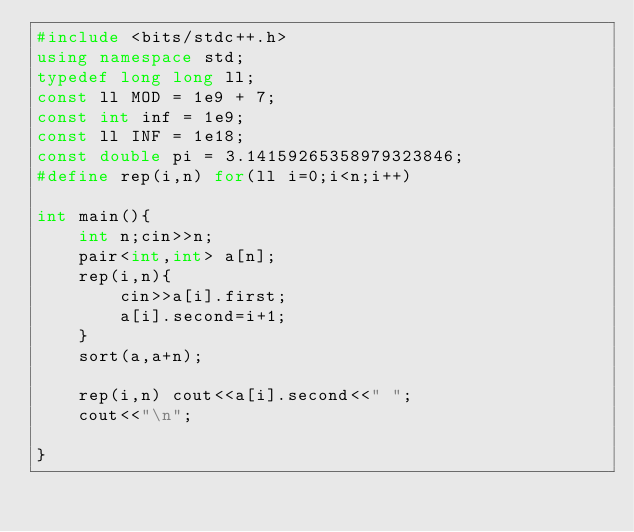<code> <loc_0><loc_0><loc_500><loc_500><_C++_>#include <bits/stdc++.h>
using namespace std;
typedef long long ll;
const ll MOD = 1e9 + 7;
const int inf = 1e9;
const ll INF = 1e18;
const double pi = 3.14159265358979323846;
#define rep(i,n) for(ll i=0;i<n;i++)

int main(){
	int n;cin>>n;
	pair<int,int> a[n];
	rep(i,n){
		cin>>a[i].first;
		a[i].second=i+1;
	}
	sort(a,a+n);

	rep(i,n) cout<<a[i].second<<" ";
	cout<<"\n";

}</code> 